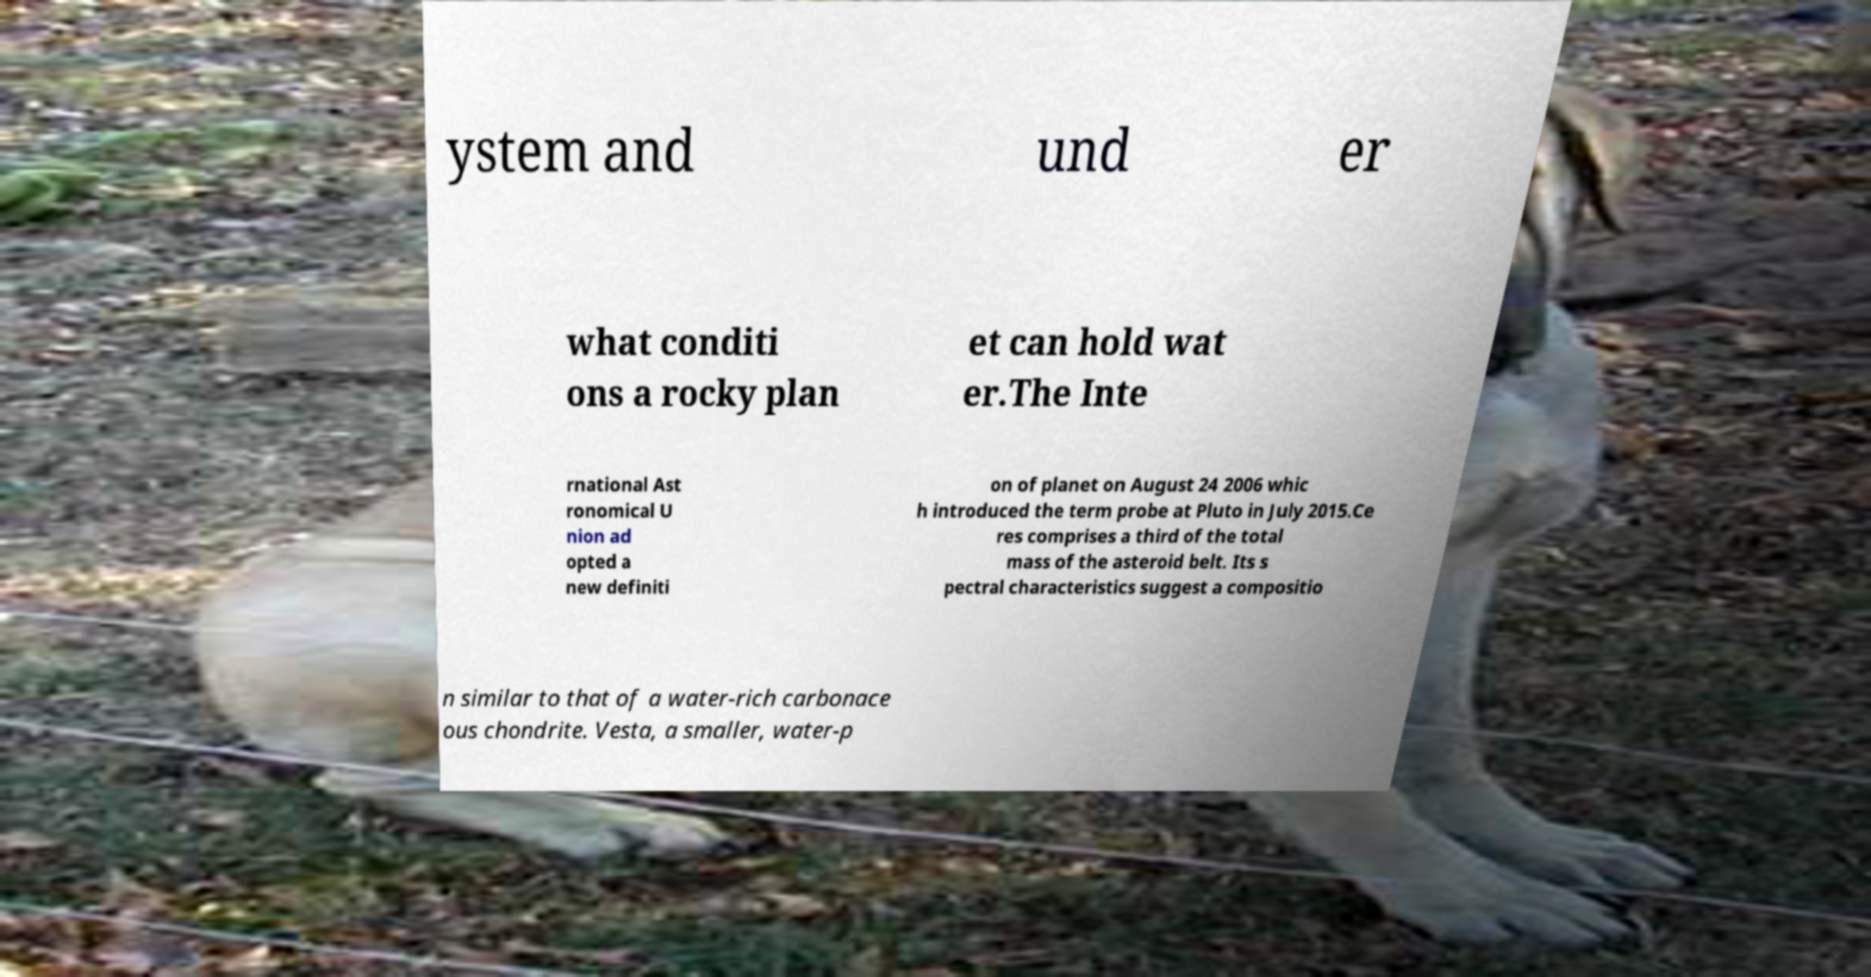Can you accurately transcribe the text from the provided image for me? ystem and und er what conditi ons a rocky plan et can hold wat er.The Inte rnational Ast ronomical U nion ad opted a new definiti on of planet on August 24 2006 whic h introduced the term probe at Pluto in July 2015.Ce res comprises a third of the total mass of the asteroid belt. Its s pectral characteristics suggest a compositio n similar to that of a water-rich carbonace ous chondrite. Vesta, a smaller, water-p 